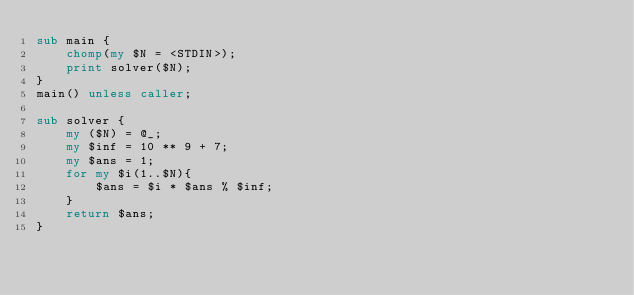Convert code to text. <code><loc_0><loc_0><loc_500><loc_500><_Perl_>sub main {
    chomp(my $N = <STDIN>);
    print solver($N);
}
main() unless caller;

sub solver {
    my ($N) = @_;
    my $inf = 10 ** 9 + 7;
    my $ans = 1;
    for my $i(1..$N){
        $ans = $i * $ans % $inf; 
    }
    return $ans;
}</code> 